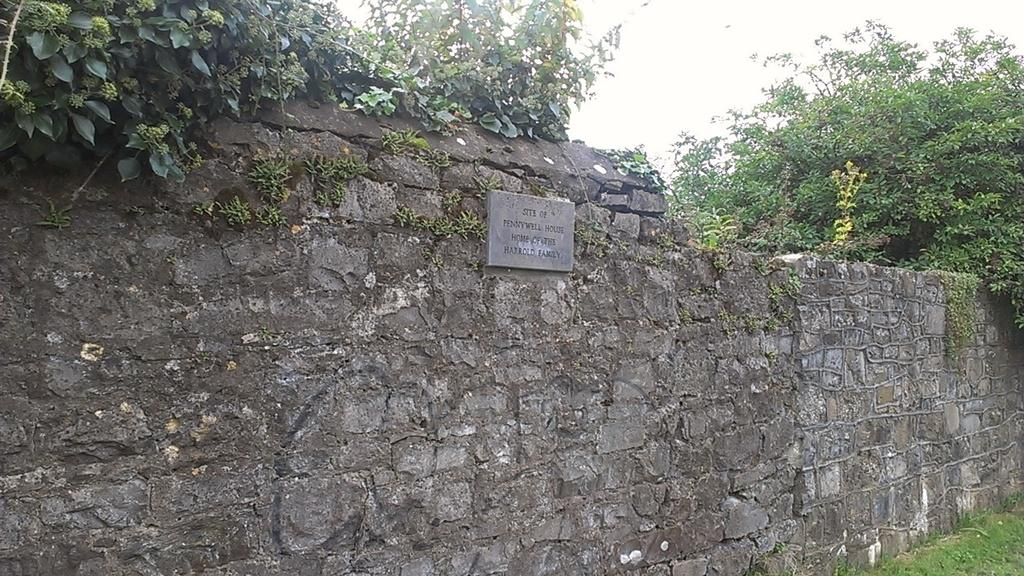What type of wall is shown in the image? There is a wall made up of stones in the image. What is attached to the wall in the image? There is a board with text on it in the image. What type of vegetation can be seen in the image? Grass and trees are visible in the image. What part of the natural environment is visible in the image? The sky is visible in the image. What type of lead is the woman holding in the image? There is no woman or lead present in the image. Is the queen mentioned or depicted in the image? There is no mention or depiction of a queen in the image. 